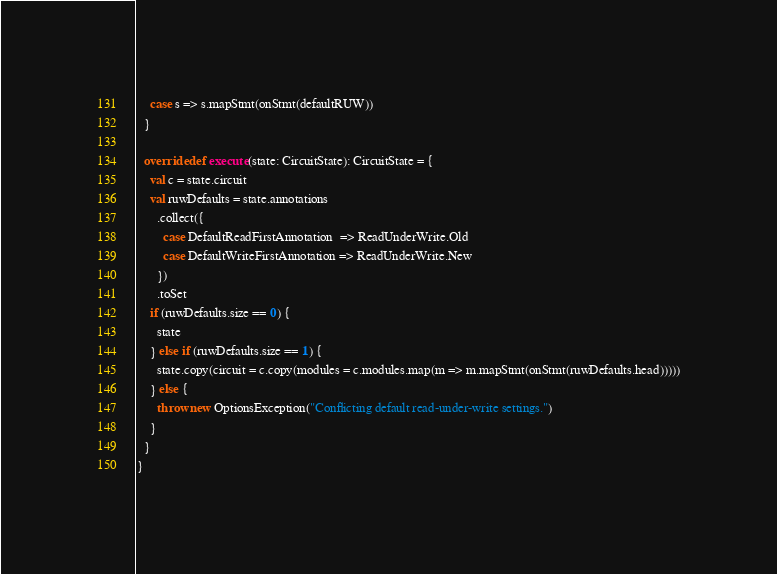<code> <loc_0><loc_0><loc_500><loc_500><_Scala_>    case s => s.mapStmt(onStmt(defaultRUW))
  }

  override def execute(state: CircuitState): CircuitState = {
    val c = state.circuit
    val ruwDefaults = state.annotations
      .collect({
        case DefaultReadFirstAnnotation  => ReadUnderWrite.Old
        case DefaultWriteFirstAnnotation => ReadUnderWrite.New
      })
      .toSet
    if (ruwDefaults.size == 0) {
      state
    } else if (ruwDefaults.size == 1) {
      state.copy(circuit = c.copy(modules = c.modules.map(m => m.mapStmt(onStmt(ruwDefaults.head)))))
    } else {
      throw new OptionsException("Conflicting default read-under-write settings.")
    }
  }
}
</code> 